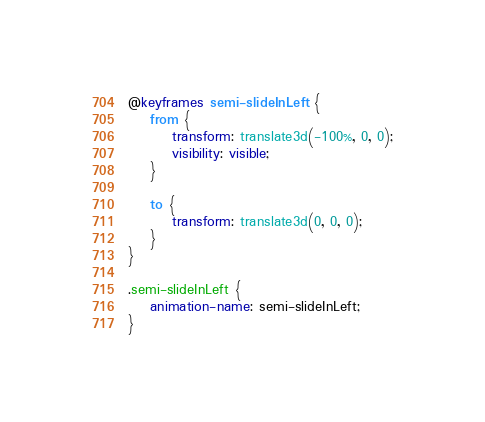Convert code to text. <code><loc_0><loc_0><loc_500><loc_500><_CSS_>@keyframes semi-slideInLeft {
    from {
        transform: translate3d(-100%, 0, 0);
        visibility: visible;
    }

    to {
        transform: translate3d(0, 0, 0);
    }
}

.semi-slideInLeft {
    animation-name: semi-slideInLeft;
}
</code> 